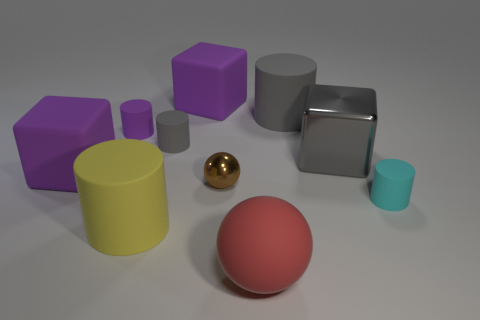Subtract all large gray cylinders. How many cylinders are left? 4 Subtract 1 blocks. How many blocks are left? 2 Subtract all purple cubes. How many cubes are left? 1 Subtract all balls. How many objects are left? 8 Subtract all metallic spheres. Subtract all tiny purple matte cylinders. How many objects are left? 8 Add 1 red spheres. How many red spheres are left? 2 Add 1 gray blocks. How many gray blocks exist? 2 Subtract 1 purple cylinders. How many objects are left? 9 Subtract all red spheres. Subtract all gray cylinders. How many spheres are left? 1 Subtract all brown cylinders. How many red balls are left? 1 